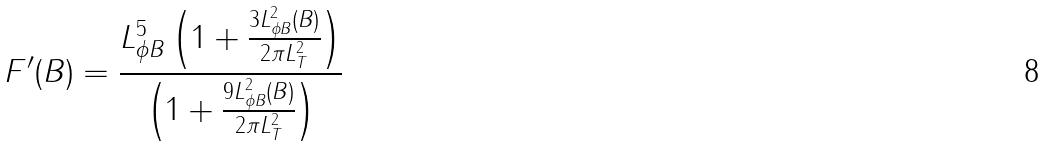<formula> <loc_0><loc_0><loc_500><loc_500>F ^ { \prime } ( B ) = \frac { L _ { \phi B } ^ { 5 } \left ( 1 + \frac { 3 L _ { \phi B } ^ { 2 } ( B ) } { 2 \pi L _ { T } ^ { 2 } } \right ) } { \left ( 1 + \frac { 9 L _ { \phi B } ^ { 2 } ( B ) } { 2 \pi L _ { T } ^ { 2 } } \right ) }</formula> 